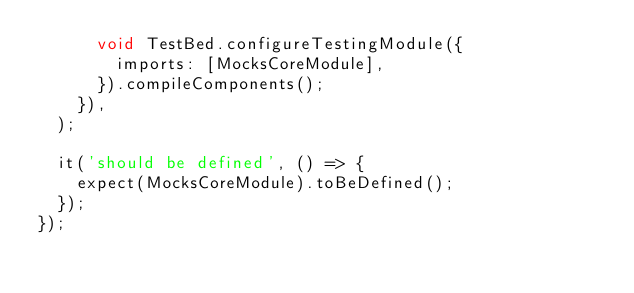Convert code to text. <code><loc_0><loc_0><loc_500><loc_500><_TypeScript_>      void TestBed.configureTestingModule({
        imports: [MocksCoreModule],
      }).compileComponents();
    }),
  );

  it('should be defined', () => {
    expect(MocksCoreModule).toBeDefined();
  });
});
</code> 